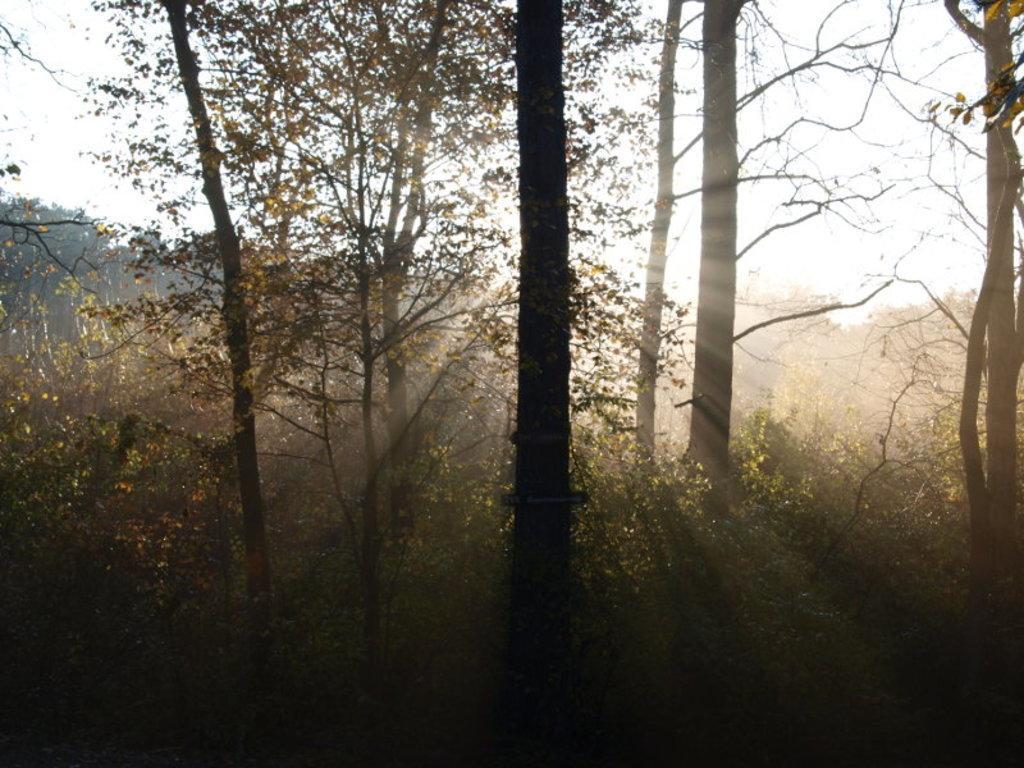Could you give a brief overview of what you see in this image? In this image, I can see trees and plants. This looks like a forest. I can see the sunlight. 